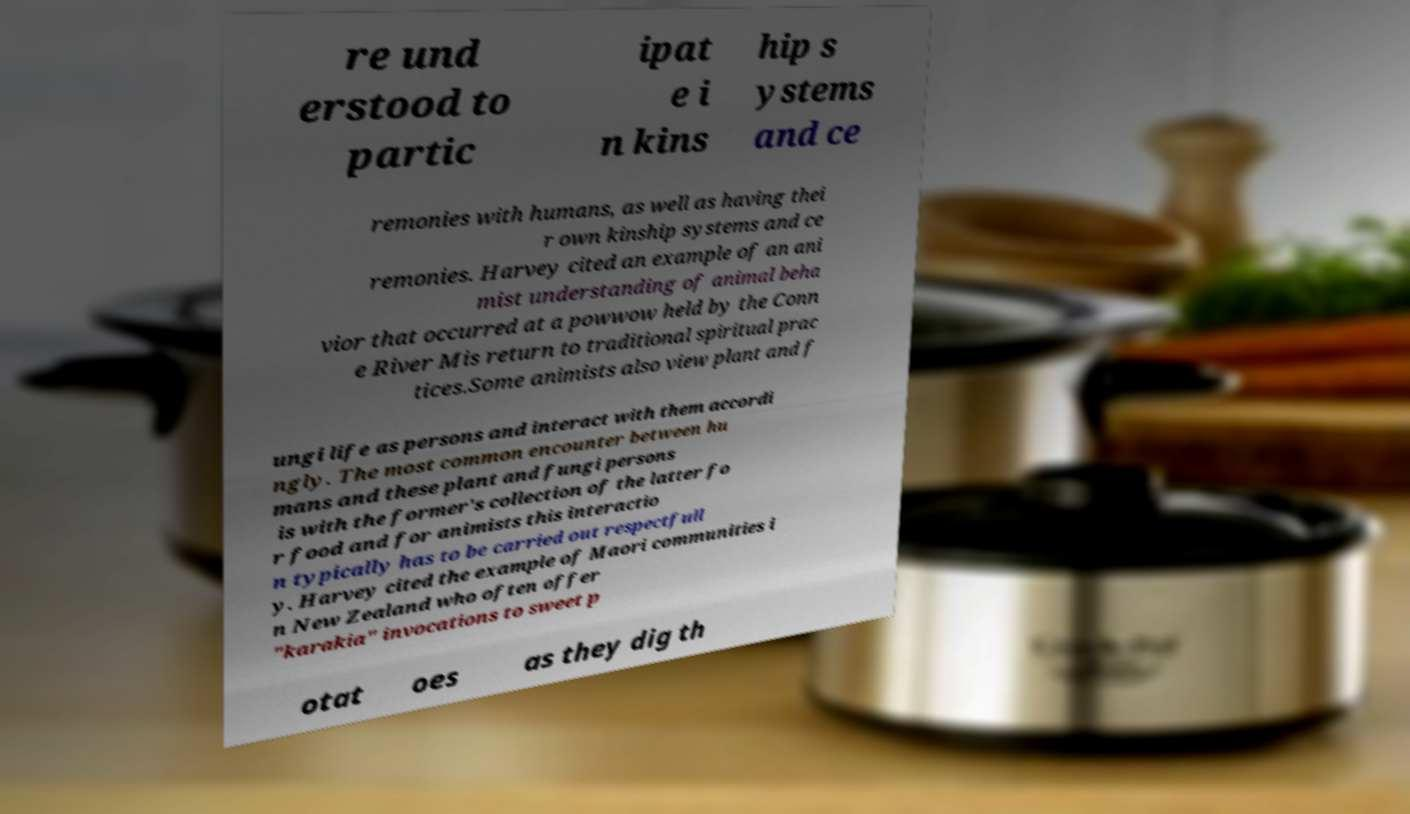What messages or text are displayed in this image? I need them in a readable, typed format. re und erstood to partic ipat e i n kins hip s ystems and ce remonies with humans, as well as having thei r own kinship systems and ce remonies. Harvey cited an example of an ani mist understanding of animal beha vior that occurred at a powwow held by the Conn e River Mis return to traditional spiritual prac tices.Some animists also view plant and f ungi life as persons and interact with them accordi ngly. The most common encounter between hu mans and these plant and fungi persons is with the former's collection of the latter fo r food and for animists this interactio n typically has to be carried out respectfull y. Harvey cited the example of Maori communities i n New Zealand who often offer "karakia" invocations to sweet p otat oes as they dig th 